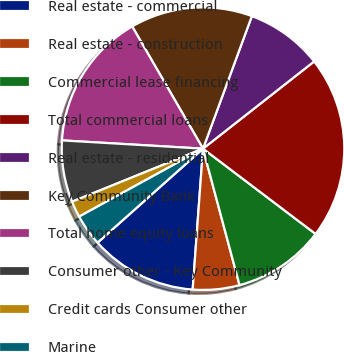Convert chart. <chart><loc_0><loc_0><loc_500><loc_500><pie_chart><fcel>Real estate - commercial<fcel>Real estate - construction<fcel>Commercial lease financing<fcel>Total commercial loans<fcel>Real estate - residential<fcel>Key Community Bank<fcel>Total home equity loans<fcel>Consumer other - Key Community<fcel>Credit cards Consumer other<fcel>Marine<nl><fcel>12.25%<fcel>5.33%<fcel>10.52%<fcel>20.91%<fcel>8.79%<fcel>13.98%<fcel>15.71%<fcel>7.06%<fcel>1.86%<fcel>3.6%<nl></chart> 